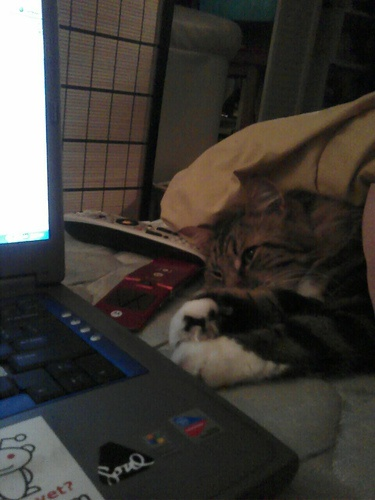Describe the objects in this image and their specific colors. I can see bed in white, black, gray, and maroon tones, laptop in white, black, gray, and navy tones, cat in white, black, and gray tones, remote in white, black, gray, and maroon tones, and remote in white, black, maroon, and gray tones in this image. 